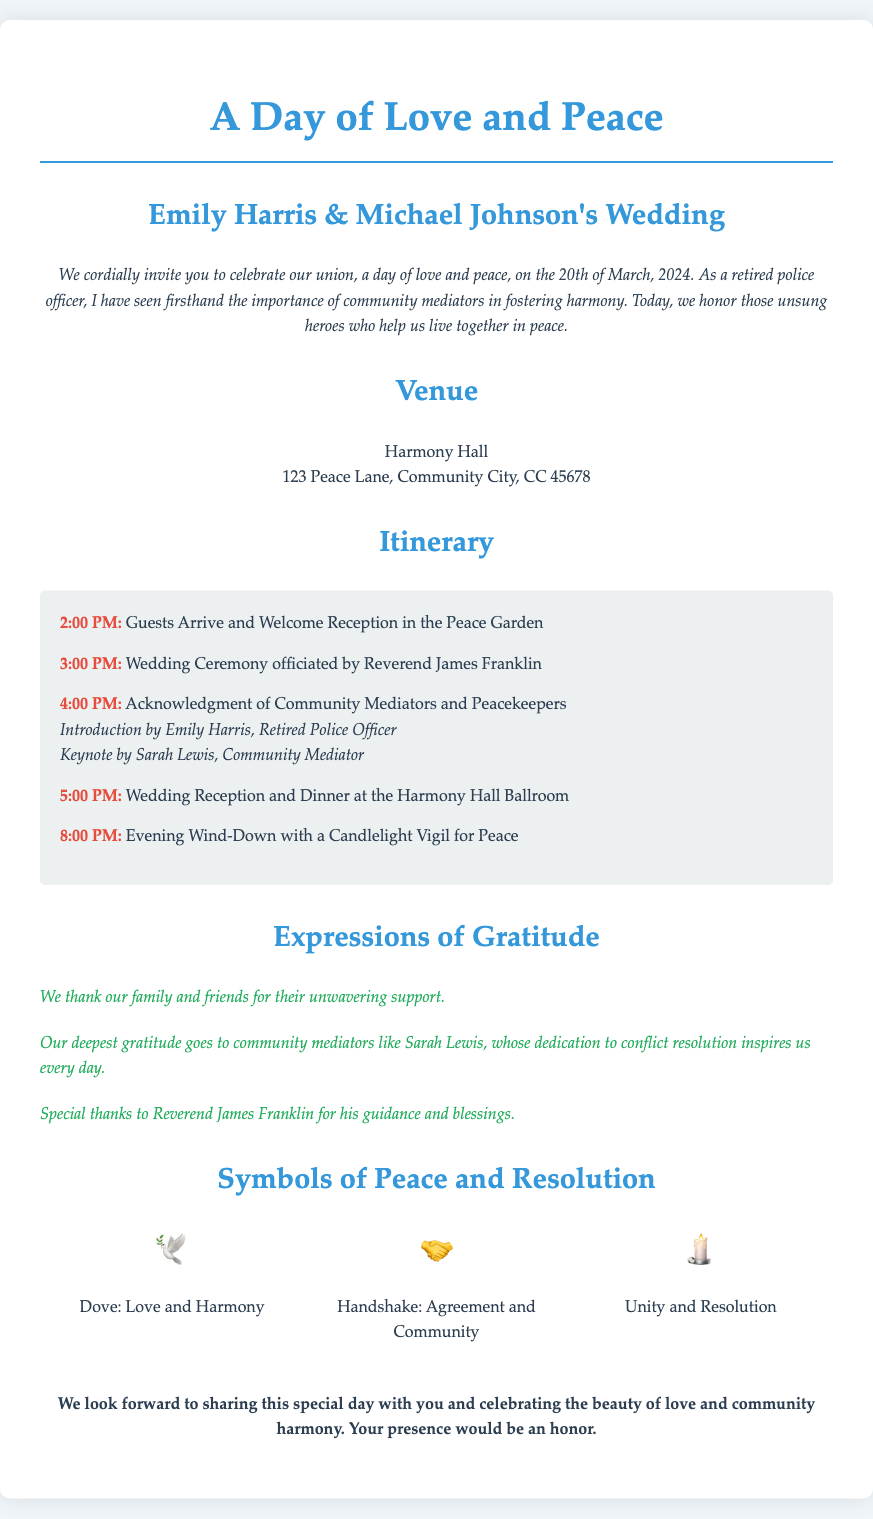What is the date of the wedding? The date of the wedding is explicitly mentioned in the invitation as the 20th of March, 2024.
Answer: 20th of March, 2024 Who will officiate the wedding ceremony? The document states that Reverend James Franklin will officiate the wedding ceremony.
Answer: Reverend James Franklin What time does the reception start? The itinerary lists that the wedding reception and dinner begin at 5:00 PM.
Answer: 5:00 PM What symbol represents love and harmony? The document includes a dove symbol representing love and harmony.
Answer: Dove Who is introduced in the acknowledgment of community mediators? Emily Harris is introduced in the acknowledgment of community mediators during the ceremony.
Answer: Emily Harris 